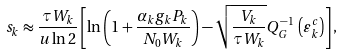<formula> <loc_0><loc_0><loc_500><loc_500>s _ { k } \approx \frac { \tau W _ { k } } { u \ln { 2 } } \left [ \ln \left ( 1 + \frac { \alpha _ { k } g _ { k } P _ { k } } { N _ { 0 } W _ { k } } \right ) - \sqrt { \frac { V _ { k } } { \tau W _ { k } } } Q _ { G } ^ { - 1 } \, \left ( { \varepsilon ^ { c } _ { k } } \right ) \right ] ,</formula> 